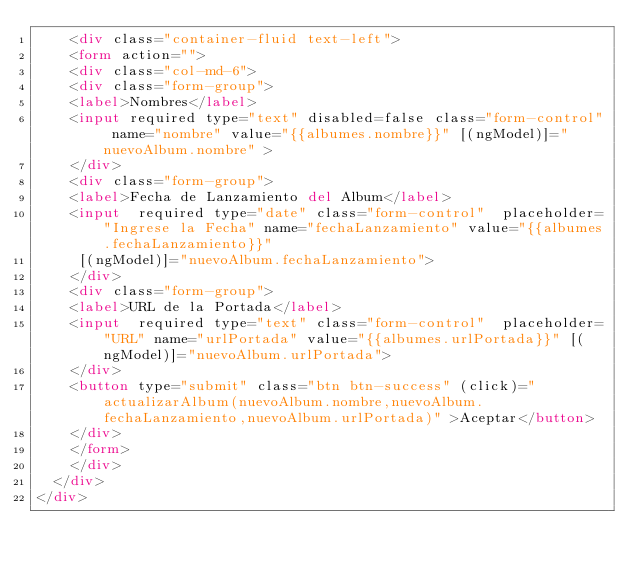Convert code to text. <code><loc_0><loc_0><loc_500><loc_500><_HTML_>    <div class="container-fluid text-left">
    <form action="">
    <div class="col-md-6">
    <div class="form-group">
    <label>Nombres</label>
    <input required type="text" disabled=false class="form-control" name="nombre" value="{{albumes.nombre}}" [(ngModel)]="nuevoAlbum.nombre" >
    </div>
    <div class="form-group">
    <label>Fecha de Lanzamiento del Album</label>
    <input  required type="date" class="form-control"  placeholder="Ingrese la Fecha" name="fechaLanzamiento" value="{{albumes.fechaLanzamiento}}" 
     [(ngModel)]="nuevoAlbum.fechaLanzamiento">
    </div>
    <div class="form-group">
    <label>URL de la Portada</label>
    <input  required type="text" class="form-control"  placeholder="URL" name="urlPortada" value="{{albumes.urlPortada}}" [(ngModel)]="nuevoAlbum.urlPortada">
    </div>
    <button type="submit" class="btn btn-success" (click)="actualizarAlbum(nuevoAlbum.nombre,nuevoAlbum.fechaLanzamiento,nuevoAlbum.urlPortada)" >Aceptar</button>
    </div>
    </form>
    </div>
  </div>
</div></code> 